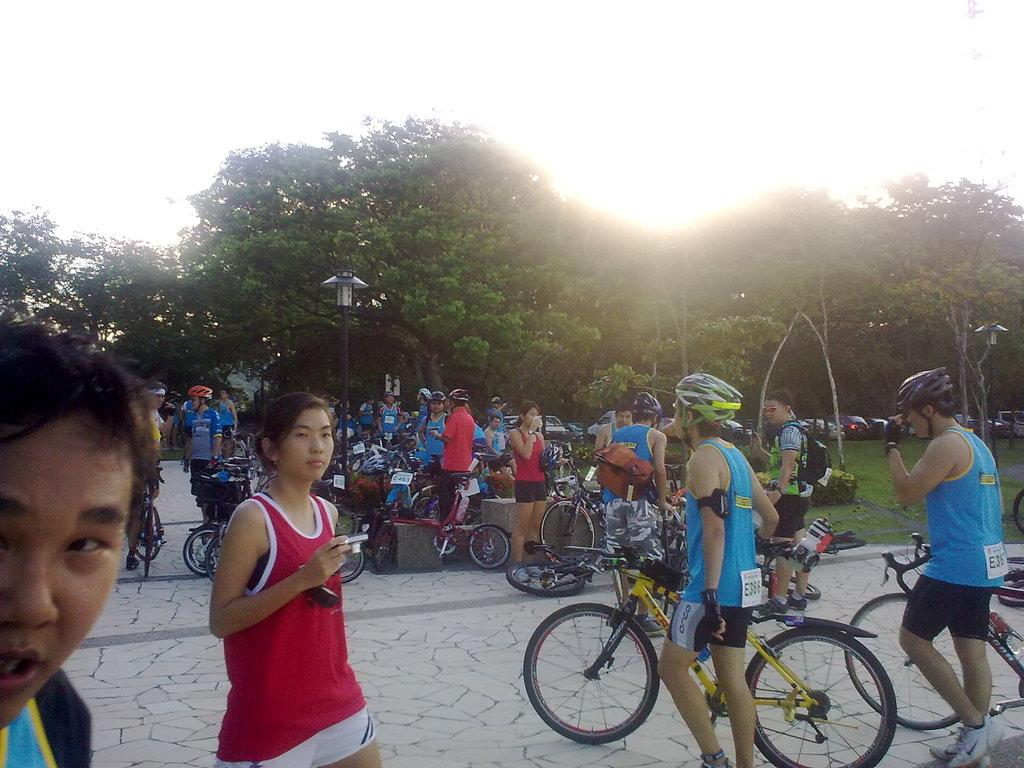How many people can be seen in the image? There are many people standing in the image. What else is present in the image besides people? There are many bicycles in the image. Can you describe the appearance of one of the people in the image? There is a lady wearing a red top in the image. What type of surface are the people and bicycles standing on? There is a floor in the image. What other object can be seen in the image? There is a lamp pole in the image. What type of natural elements are present in the image? There are many trees in the image. How many balloons are being carried by the people in the image? There are no balloons present in the image. What direction are the people walking in the image? The image does not show the people walking; they are standing still. 